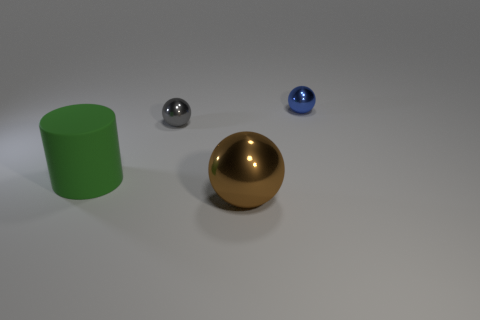What can you deduce about the lighting in this image? The lighting seems to be coming from above, as indicated by the soft shadows under the objects, suggesting an overhead diffused light source, perhaps in a studio setting. 